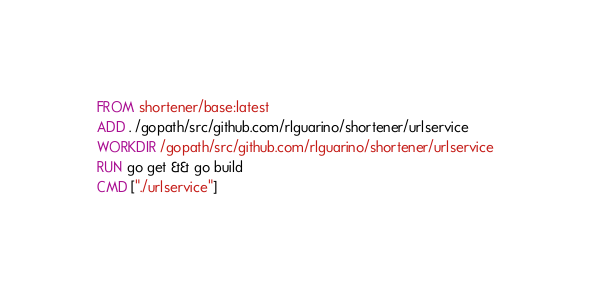Convert code to text. <code><loc_0><loc_0><loc_500><loc_500><_Dockerfile_>FROM shortener/base:latest
ADD . /gopath/src/github.com/rlguarino/shortener/urlservice
WORKDIR /gopath/src/github.com/rlguarino/shortener/urlservice
RUN go get && go build
CMD ["./urlservice"]</code> 